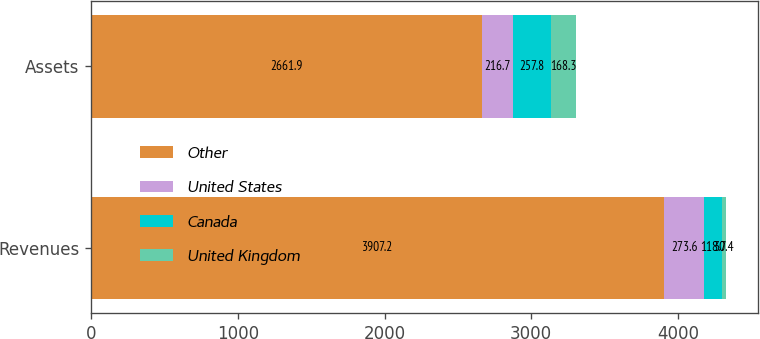Convert chart. <chart><loc_0><loc_0><loc_500><loc_500><stacked_bar_chart><ecel><fcel>Revenues<fcel>Assets<nl><fcel>Other<fcel>3907.2<fcel>2661.9<nl><fcel>United States<fcel>273.6<fcel>216.7<nl><fcel>Canada<fcel>118.7<fcel>257.8<nl><fcel>United Kingdom<fcel>30.4<fcel>168.3<nl></chart> 